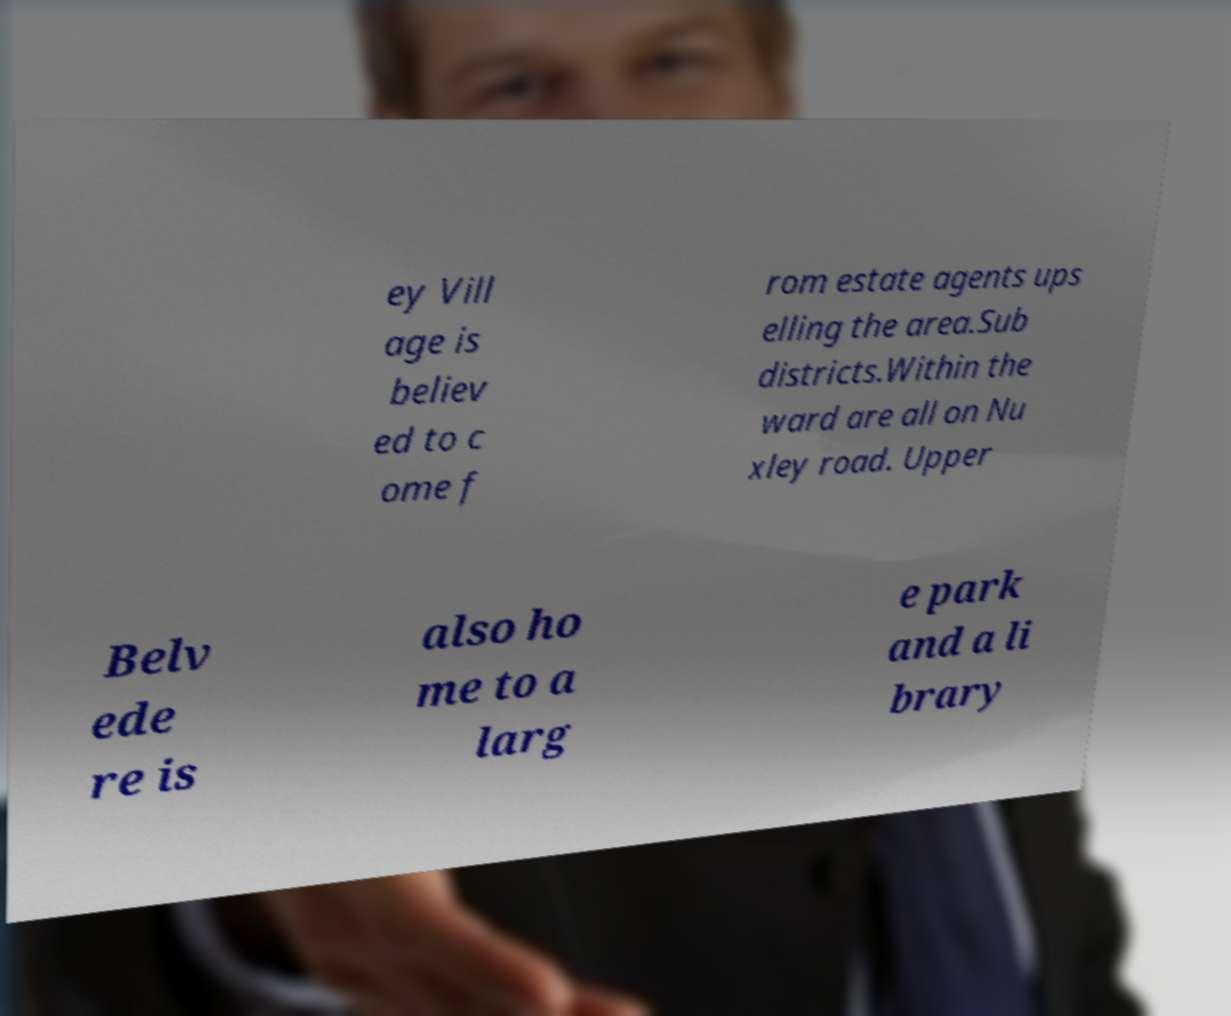Please identify and transcribe the text found in this image. ey Vill age is believ ed to c ome f rom estate agents ups elling the area.Sub districts.Within the ward are all on Nu xley road. Upper Belv ede re is also ho me to a larg e park and a li brary 